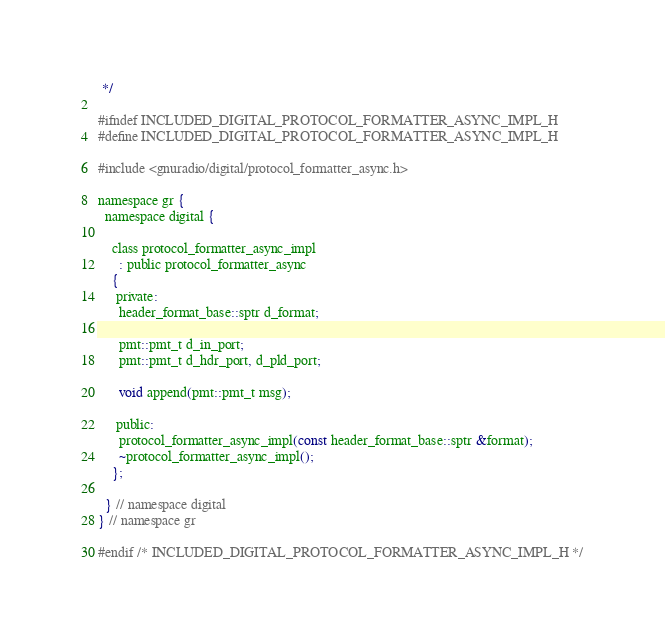<code> <loc_0><loc_0><loc_500><loc_500><_C_> */

#ifndef INCLUDED_DIGITAL_PROTOCOL_FORMATTER_ASYNC_IMPL_H
#define INCLUDED_DIGITAL_PROTOCOL_FORMATTER_ASYNC_IMPL_H

#include <gnuradio/digital/protocol_formatter_async.h>

namespace gr {
  namespace digital {

    class protocol_formatter_async_impl
      : public protocol_formatter_async
    {
     private:
      header_format_base::sptr d_format;

      pmt::pmt_t d_in_port;
      pmt::pmt_t d_hdr_port, d_pld_port;

      void append(pmt::pmt_t msg);

     public:
      protocol_formatter_async_impl(const header_format_base::sptr &format);
      ~protocol_formatter_async_impl();
    };

  } // namespace digital
} // namespace gr

#endif /* INCLUDED_DIGITAL_PROTOCOL_FORMATTER_ASYNC_IMPL_H */
</code> 